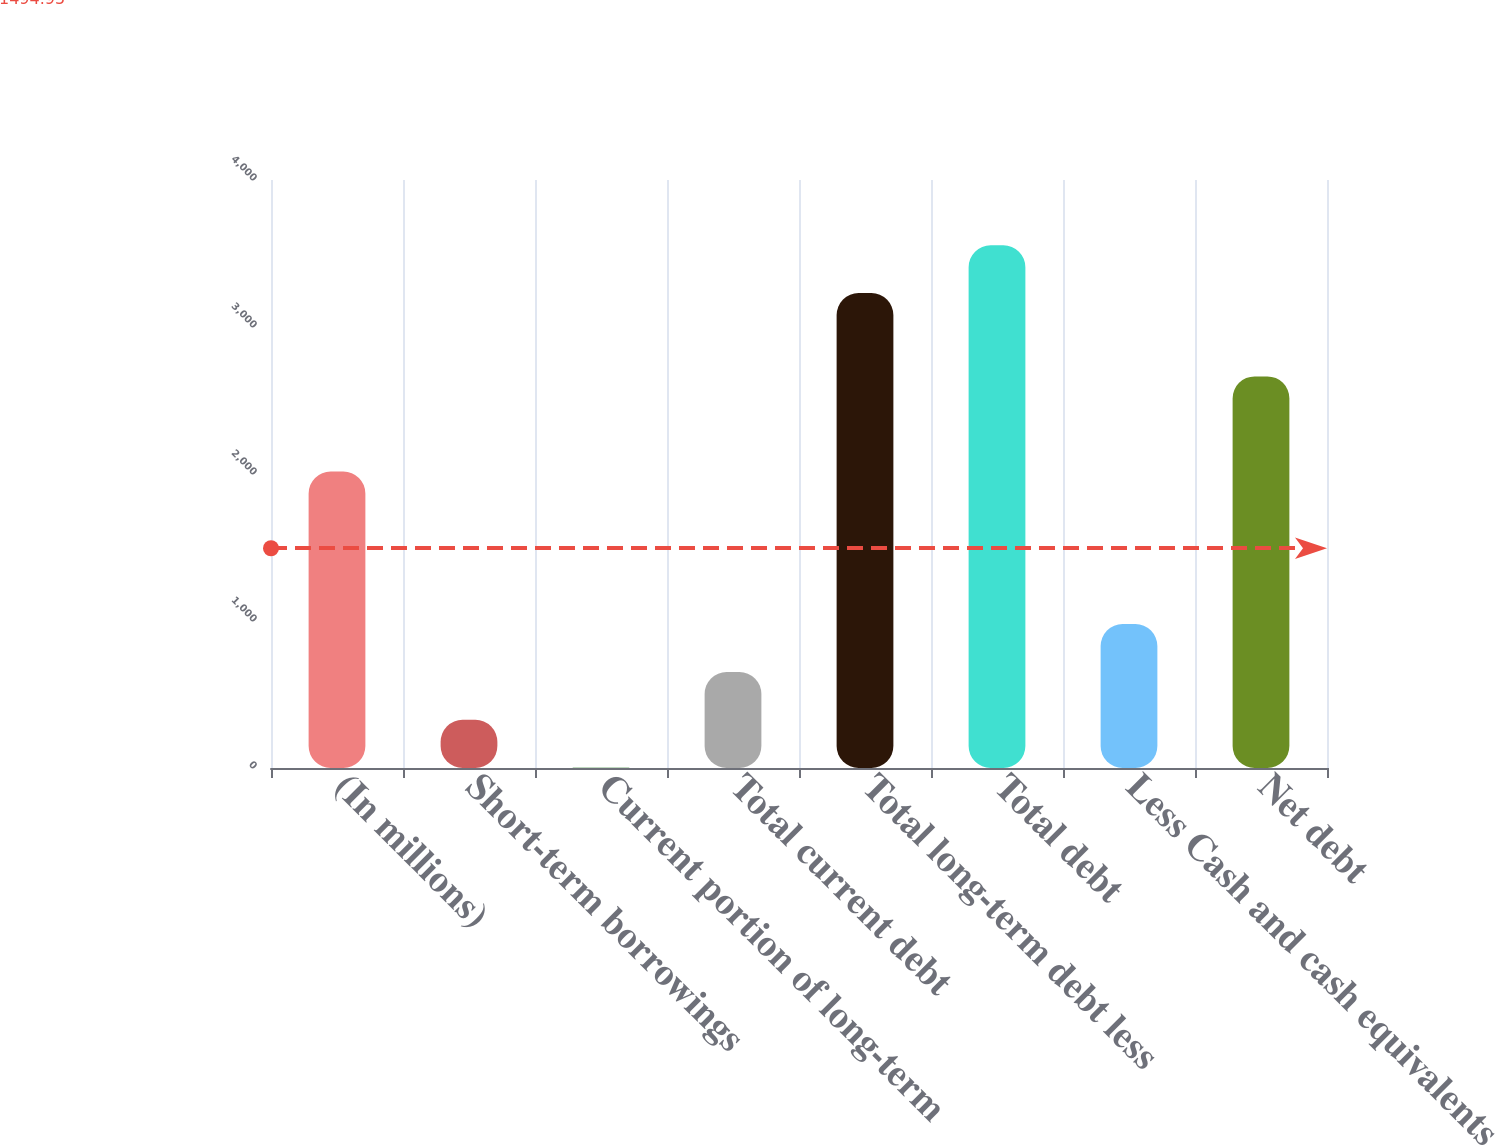Convert chart. <chart><loc_0><loc_0><loc_500><loc_500><bar_chart><fcel>(In millions)<fcel>Short-term borrowings<fcel>Current portion of long-term<fcel>Total current debt<fcel>Total long-term debt less<fcel>Total debt<fcel>Less Cash and cash equivalents<fcel>Net debt<nl><fcel>2017<fcel>327.78<fcel>2.2<fcel>653.36<fcel>3230.5<fcel>3556.08<fcel>978.94<fcel>2664<nl></chart> 